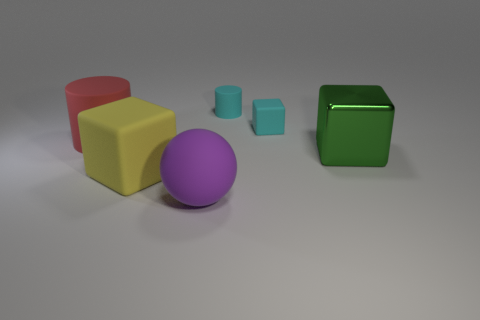Add 1 large brown metallic things. How many objects exist? 7 Subtract all balls. How many objects are left? 5 Subtract all big cyan cylinders. Subtract all big purple balls. How many objects are left? 5 Add 1 tiny rubber things. How many tiny rubber things are left? 3 Add 2 tiny blue shiny cylinders. How many tiny blue shiny cylinders exist? 2 Subtract 0 gray blocks. How many objects are left? 6 